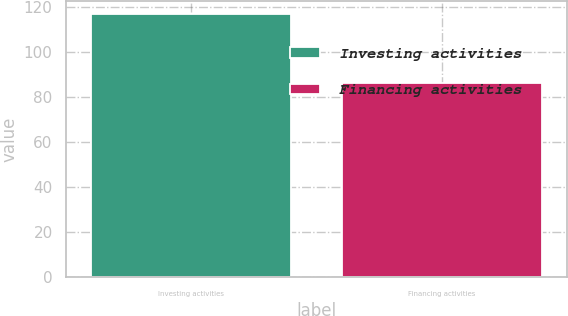Convert chart. <chart><loc_0><loc_0><loc_500><loc_500><bar_chart><fcel>Investing activities<fcel>Financing activities<nl><fcel>116.8<fcel>86.2<nl></chart> 